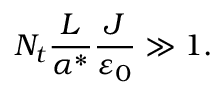<formula> <loc_0><loc_0><loc_500><loc_500>N _ { t } \frac { L } { { \alpha } ^ { * } } \frac { J } { { \varepsilon } _ { 0 } } \gg 1 .</formula> 